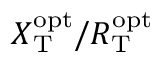<formula> <loc_0><loc_0><loc_500><loc_500>X _ { T } ^ { o p t } / R _ { T } ^ { o p t }</formula> 